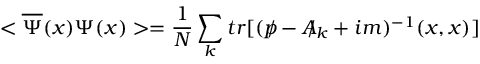Convert formula to latex. <formula><loc_0><loc_0><loc_500><loc_500>< \overline { \Psi } ( x ) \Psi ( x ) > = \frac { 1 } { N } \sum _ { k } t r [ ( p \, / - A \, / _ { k } + i m ) ^ { - 1 } ( x , x ) ]</formula> 